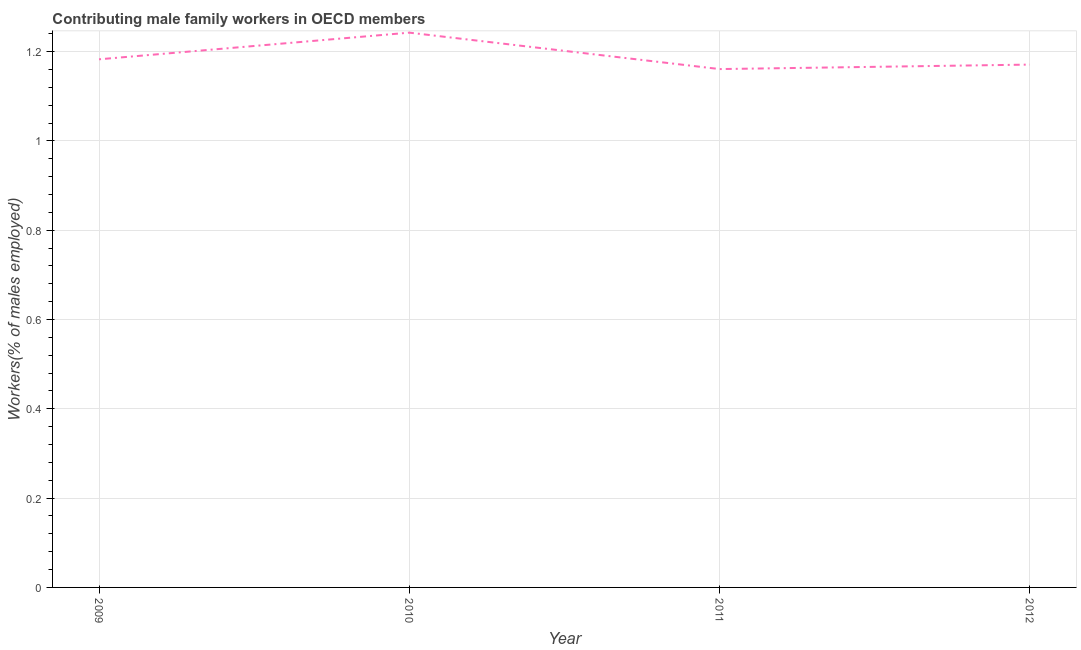What is the contributing male family workers in 2010?
Keep it short and to the point. 1.24. Across all years, what is the maximum contributing male family workers?
Provide a succinct answer. 1.24. Across all years, what is the minimum contributing male family workers?
Your answer should be very brief. 1.16. In which year was the contributing male family workers maximum?
Ensure brevity in your answer.  2010. What is the sum of the contributing male family workers?
Provide a short and direct response. 4.76. What is the difference between the contributing male family workers in 2010 and 2012?
Keep it short and to the point. 0.07. What is the average contributing male family workers per year?
Give a very brief answer. 1.19. What is the median contributing male family workers?
Offer a terse response. 1.18. Do a majority of the years between 2011 and 2012 (inclusive) have contributing male family workers greater than 0.92 %?
Make the answer very short. Yes. What is the ratio of the contributing male family workers in 2010 to that in 2012?
Give a very brief answer. 1.06. Is the difference between the contributing male family workers in 2009 and 2011 greater than the difference between any two years?
Keep it short and to the point. No. What is the difference between the highest and the second highest contributing male family workers?
Keep it short and to the point. 0.06. What is the difference between the highest and the lowest contributing male family workers?
Your answer should be compact. 0.08. How many years are there in the graph?
Provide a short and direct response. 4. What is the difference between two consecutive major ticks on the Y-axis?
Make the answer very short. 0.2. Are the values on the major ticks of Y-axis written in scientific E-notation?
Your answer should be compact. No. What is the title of the graph?
Offer a very short reply. Contributing male family workers in OECD members. What is the label or title of the Y-axis?
Make the answer very short. Workers(% of males employed). What is the Workers(% of males employed) in 2009?
Keep it short and to the point. 1.18. What is the Workers(% of males employed) of 2010?
Provide a short and direct response. 1.24. What is the Workers(% of males employed) of 2011?
Give a very brief answer. 1.16. What is the Workers(% of males employed) of 2012?
Offer a terse response. 1.17. What is the difference between the Workers(% of males employed) in 2009 and 2010?
Offer a very short reply. -0.06. What is the difference between the Workers(% of males employed) in 2009 and 2011?
Your answer should be very brief. 0.02. What is the difference between the Workers(% of males employed) in 2009 and 2012?
Ensure brevity in your answer.  0.01. What is the difference between the Workers(% of males employed) in 2010 and 2011?
Your answer should be compact. 0.08. What is the difference between the Workers(% of males employed) in 2010 and 2012?
Offer a very short reply. 0.07. What is the difference between the Workers(% of males employed) in 2011 and 2012?
Ensure brevity in your answer.  -0.01. What is the ratio of the Workers(% of males employed) in 2009 to that in 2011?
Your answer should be very brief. 1.02. What is the ratio of the Workers(% of males employed) in 2009 to that in 2012?
Keep it short and to the point. 1.01. What is the ratio of the Workers(% of males employed) in 2010 to that in 2011?
Provide a short and direct response. 1.07. What is the ratio of the Workers(% of males employed) in 2010 to that in 2012?
Provide a short and direct response. 1.06. 